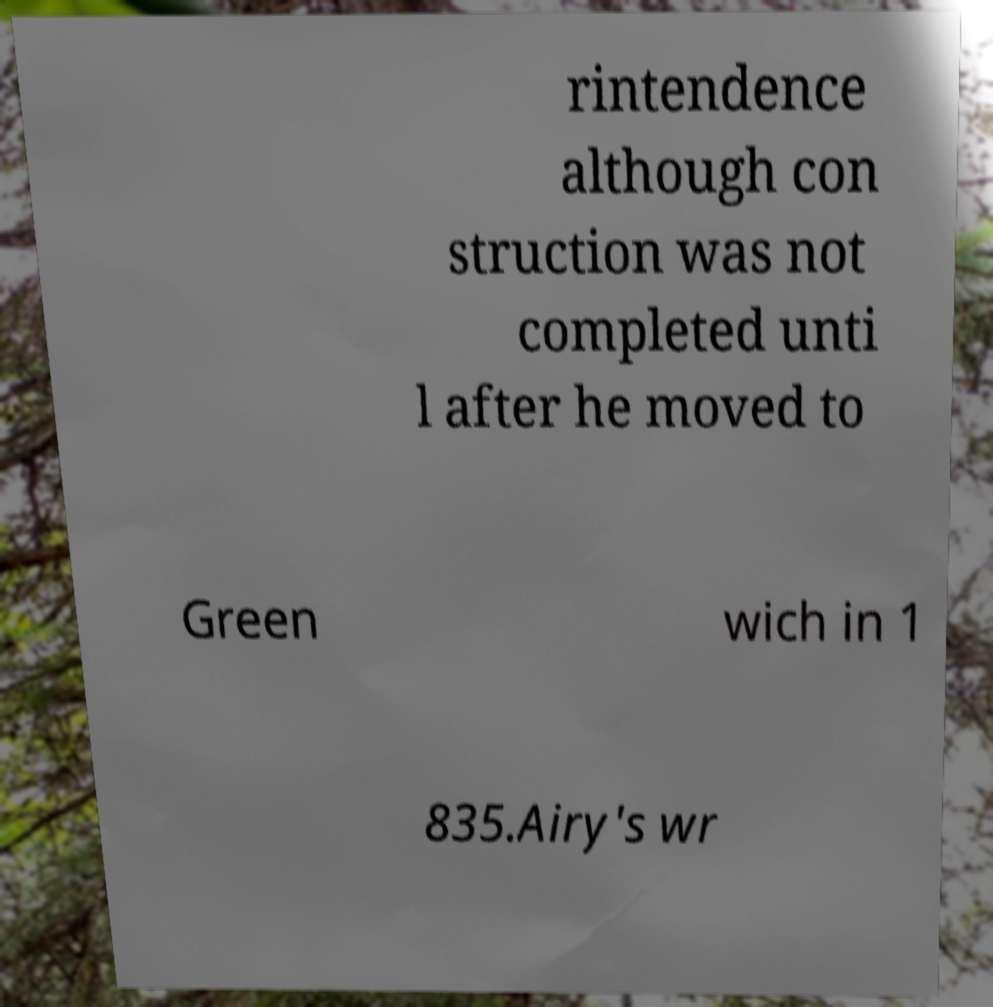Please identify and transcribe the text found in this image. rintendence although con struction was not completed unti l after he moved to Green wich in 1 835.Airy's wr 